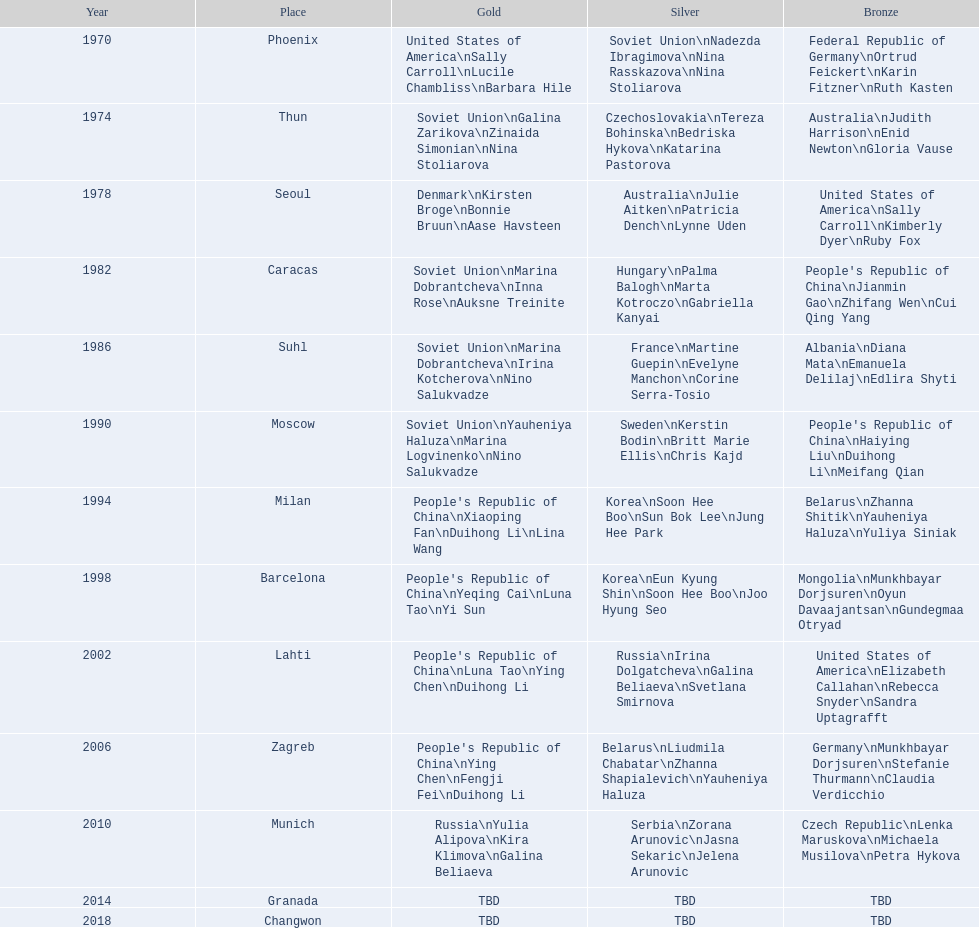Which location is mentioned first in this chart? Phoenix. 